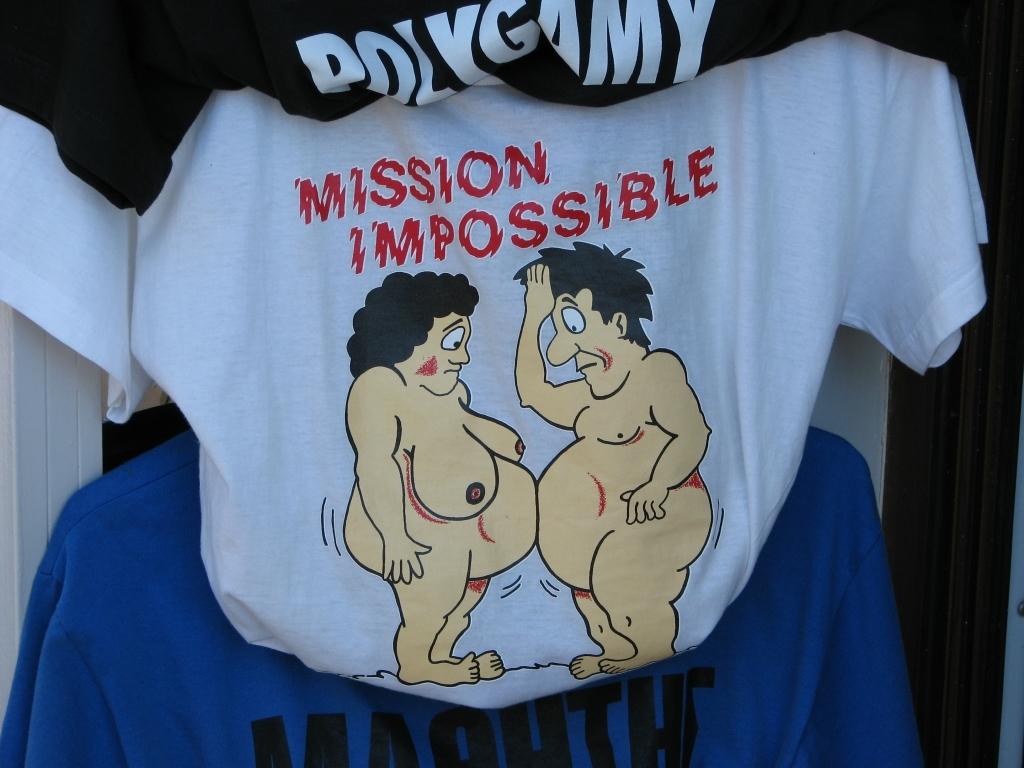What is the tagline of the shirt?
Make the answer very short. Mission impossible. What is written on the black shirt?
Offer a terse response. Polygamy. 